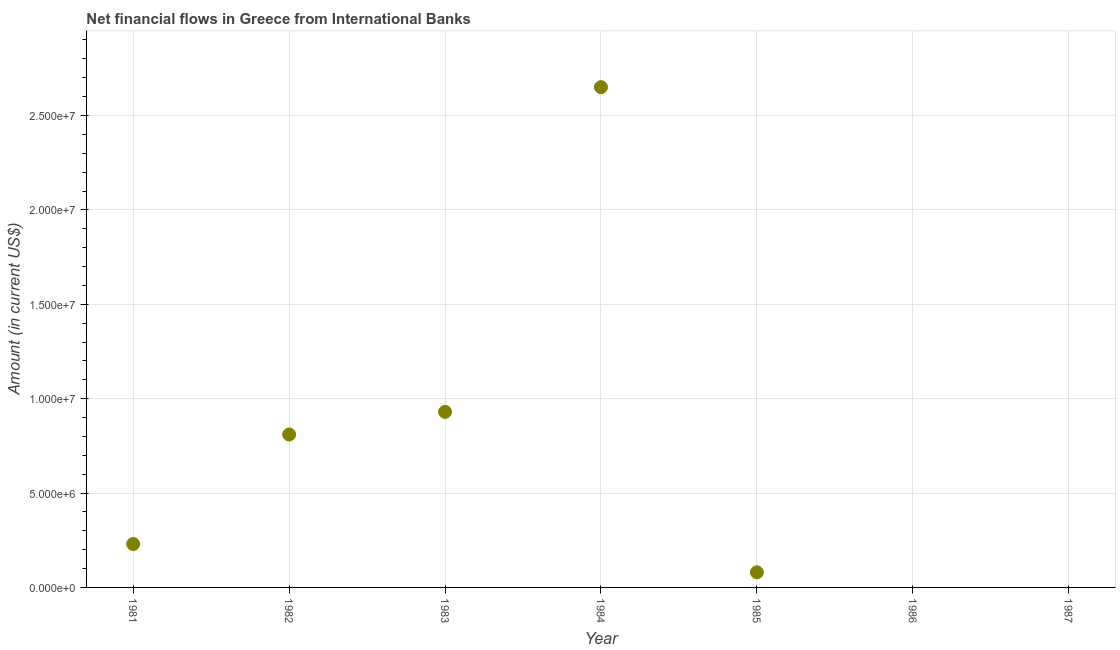What is the net financial flows from ibrd in 1985?
Provide a short and direct response. 7.99e+05. Across all years, what is the maximum net financial flows from ibrd?
Offer a very short reply. 2.65e+07. Across all years, what is the minimum net financial flows from ibrd?
Your response must be concise. 0. In which year was the net financial flows from ibrd maximum?
Ensure brevity in your answer.  1984. What is the sum of the net financial flows from ibrd?
Your answer should be compact. 4.70e+07. What is the difference between the net financial flows from ibrd in 1982 and 1983?
Offer a very short reply. -1.20e+06. What is the average net financial flows from ibrd per year?
Keep it short and to the point. 6.71e+06. What is the median net financial flows from ibrd?
Give a very brief answer. 2.30e+06. In how many years, is the net financial flows from ibrd greater than 24000000 US$?
Offer a terse response. 1. What is the ratio of the net financial flows from ibrd in 1982 to that in 1984?
Make the answer very short. 0.31. What is the difference between the highest and the second highest net financial flows from ibrd?
Your answer should be very brief. 1.72e+07. What is the difference between the highest and the lowest net financial flows from ibrd?
Your answer should be compact. 2.65e+07. Does the graph contain any zero values?
Offer a terse response. Yes. Does the graph contain grids?
Provide a succinct answer. Yes. What is the title of the graph?
Make the answer very short. Net financial flows in Greece from International Banks. What is the label or title of the Y-axis?
Your answer should be compact. Amount (in current US$). What is the Amount (in current US$) in 1981?
Ensure brevity in your answer.  2.30e+06. What is the Amount (in current US$) in 1982?
Offer a very short reply. 8.10e+06. What is the Amount (in current US$) in 1983?
Your answer should be compact. 9.30e+06. What is the Amount (in current US$) in 1984?
Ensure brevity in your answer.  2.65e+07. What is the Amount (in current US$) in 1985?
Your response must be concise. 7.99e+05. What is the Amount (in current US$) in 1986?
Keep it short and to the point. 0. What is the difference between the Amount (in current US$) in 1981 and 1982?
Your response must be concise. -5.80e+06. What is the difference between the Amount (in current US$) in 1981 and 1983?
Provide a short and direct response. -7.00e+06. What is the difference between the Amount (in current US$) in 1981 and 1984?
Your answer should be very brief. -2.42e+07. What is the difference between the Amount (in current US$) in 1981 and 1985?
Provide a short and direct response. 1.50e+06. What is the difference between the Amount (in current US$) in 1982 and 1983?
Your answer should be very brief. -1.20e+06. What is the difference between the Amount (in current US$) in 1982 and 1984?
Your answer should be compact. -1.84e+07. What is the difference between the Amount (in current US$) in 1982 and 1985?
Your answer should be compact. 7.30e+06. What is the difference between the Amount (in current US$) in 1983 and 1984?
Your response must be concise. -1.72e+07. What is the difference between the Amount (in current US$) in 1983 and 1985?
Ensure brevity in your answer.  8.50e+06. What is the difference between the Amount (in current US$) in 1984 and 1985?
Give a very brief answer. 2.57e+07. What is the ratio of the Amount (in current US$) in 1981 to that in 1982?
Make the answer very short. 0.28. What is the ratio of the Amount (in current US$) in 1981 to that in 1983?
Your answer should be very brief. 0.25. What is the ratio of the Amount (in current US$) in 1981 to that in 1984?
Give a very brief answer. 0.09. What is the ratio of the Amount (in current US$) in 1981 to that in 1985?
Your response must be concise. 2.88. What is the ratio of the Amount (in current US$) in 1982 to that in 1983?
Your response must be concise. 0.87. What is the ratio of the Amount (in current US$) in 1982 to that in 1984?
Keep it short and to the point. 0.31. What is the ratio of the Amount (in current US$) in 1982 to that in 1985?
Offer a very short reply. 10.14. What is the ratio of the Amount (in current US$) in 1983 to that in 1984?
Make the answer very short. 0.35. What is the ratio of the Amount (in current US$) in 1983 to that in 1985?
Offer a terse response. 11.64. What is the ratio of the Amount (in current US$) in 1984 to that in 1985?
Offer a terse response. 33.17. 